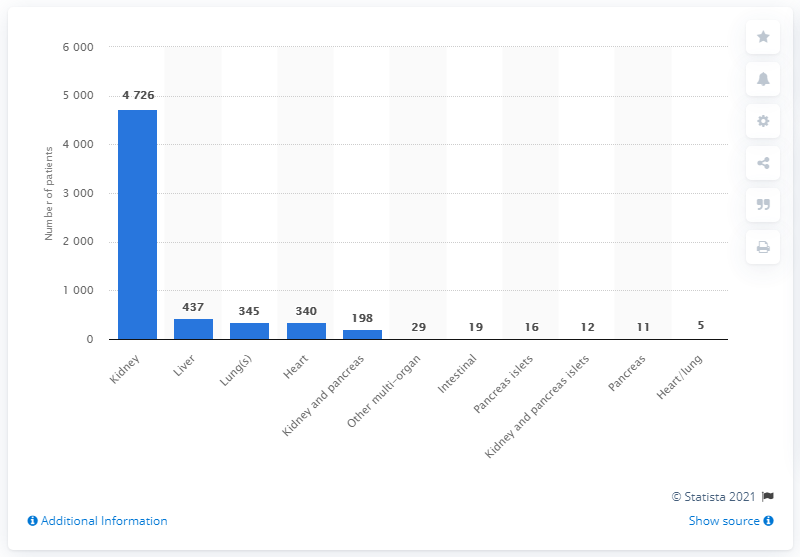Mention a couple of crucial points in this snapshot. There were 345 individuals currently on the waiting list for a lung transplant. As of the end of March 2020, there were 437 liver transplant patients. 